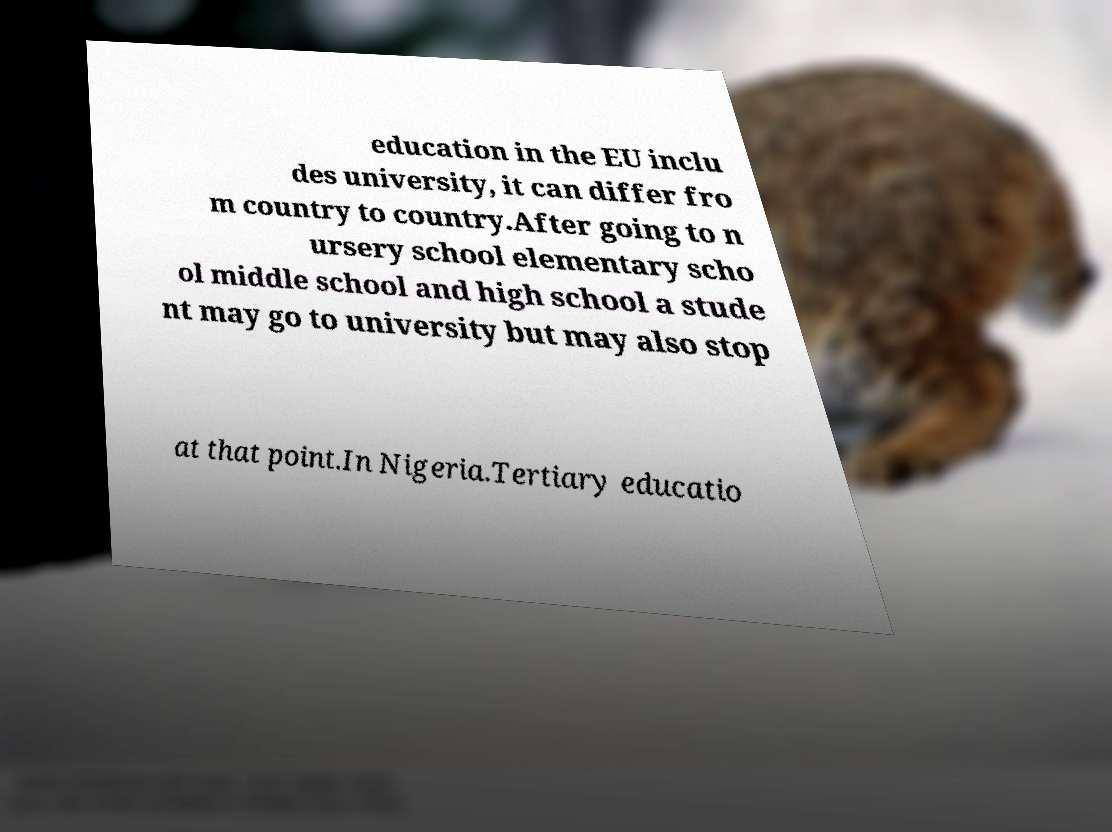Please identify and transcribe the text found in this image. education in the EU inclu des university, it can differ fro m country to country.After going to n ursery school elementary scho ol middle school and high school a stude nt may go to university but may also stop at that point.In Nigeria.Tertiary educatio 